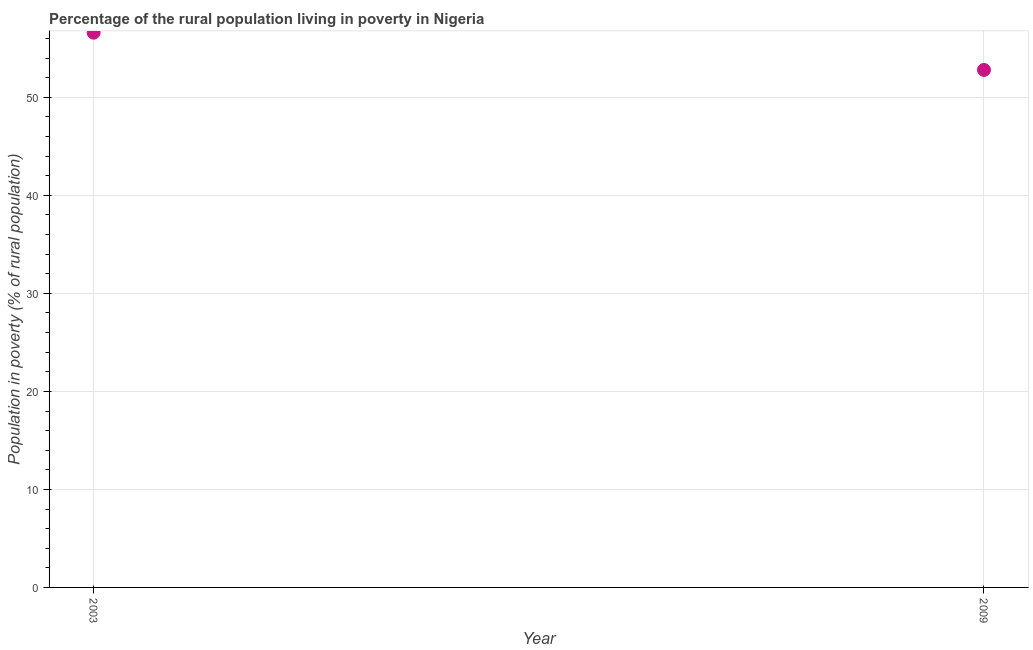What is the percentage of rural population living below poverty line in 2003?
Offer a terse response. 56.6. Across all years, what is the maximum percentage of rural population living below poverty line?
Give a very brief answer. 56.6. Across all years, what is the minimum percentage of rural population living below poverty line?
Offer a terse response. 52.8. In which year was the percentage of rural population living below poverty line maximum?
Provide a succinct answer. 2003. What is the sum of the percentage of rural population living below poverty line?
Offer a very short reply. 109.4. What is the difference between the percentage of rural population living below poverty line in 2003 and 2009?
Provide a short and direct response. 3.8. What is the average percentage of rural population living below poverty line per year?
Ensure brevity in your answer.  54.7. What is the median percentage of rural population living below poverty line?
Offer a terse response. 54.7. Do a majority of the years between 2003 and 2009 (inclusive) have percentage of rural population living below poverty line greater than 50 %?
Your answer should be very brief. Yes. What is the ratio of the percentage of rural population living below poverty line in 2003 to that in 2009?
Offer a very short reply. 1.07. In how many years, is the percentage of rural population living below poverty line greater than the average percentage of rural population living below poverty line taken over all years?
Your answer should be compact. 1. How many years are there in the graph?
Your answer should be compact. 2. What is the difference between two consecutive major ticks on the Y-axis?
Offer a terse response. 10. Does the graph contain any zero values?
Ensure brevity in your answer.  No. What is the title of the graph?
Keep it short and to the point. Percentage of the rural population living in poverty in Nigeria. What is the label or title of the Y-axis?
Offer a very short reply. Population in poverty (% of rural population). What is the Population in poverty (% of rural population) in 2003?
Your answer should be very brief. 56.6. What is the Population in poverty (% of rural population) in 2009?
Offer a very short reply. 52.8. What is the ratio of the Population in poverty (% of rural population) in 2003 to that in 2009?
Your answer should be very brief. 1.07. 